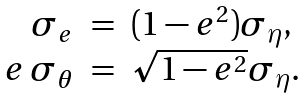Convert formula to latex. <formula><loc_0><loc_0><loc_500><loc_500>\begin{array} { r c l } \sigma _ { e } & = & ( 1 - e ^ { 2 } ) \sigma _ { \eta } , \\ e \, \sigma _ { \theta } & = & \sqrt { 1 - e ^ { 2 } } \sigma _ { \eta } . \end{array}</formula> 